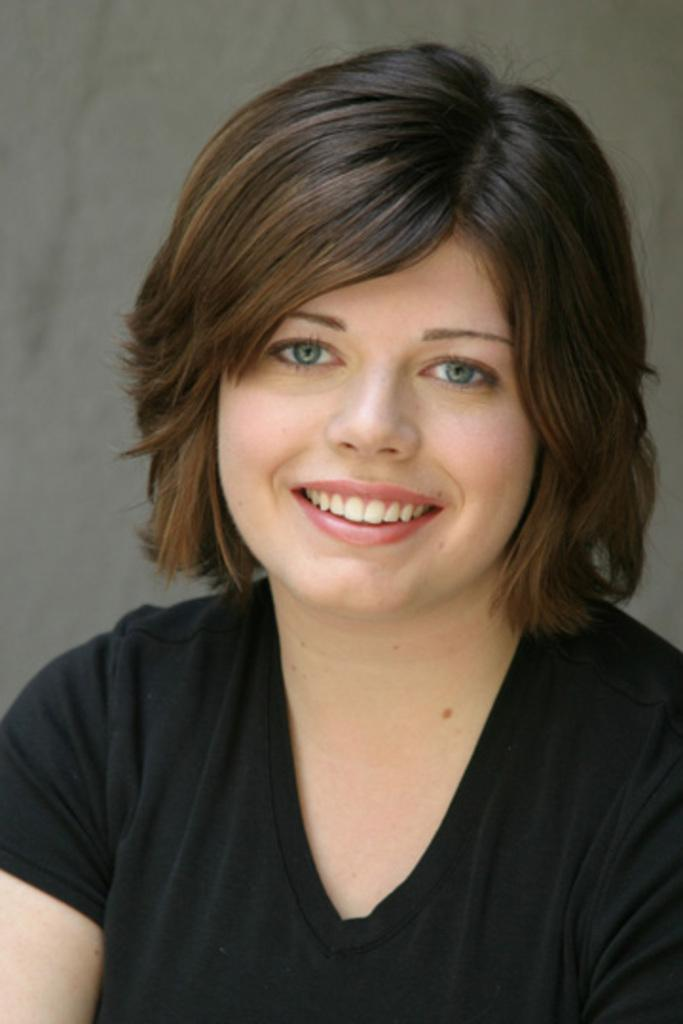Who is the main subject in the image? There is a lady in the image. What is the lady wearing in the image? The lady is wearing a T-shirt in the image. What can be seen behind the lady in the image? There is a background visible in the image. What type of ring is the lady wearing on her finger in the image? There is no ring visible on the lady's finger in the image. What is the lady sitting on in the image? The provided facts do not mention any table or seating arrangement, so we cannot determine what the lady is sitting on in the image. 